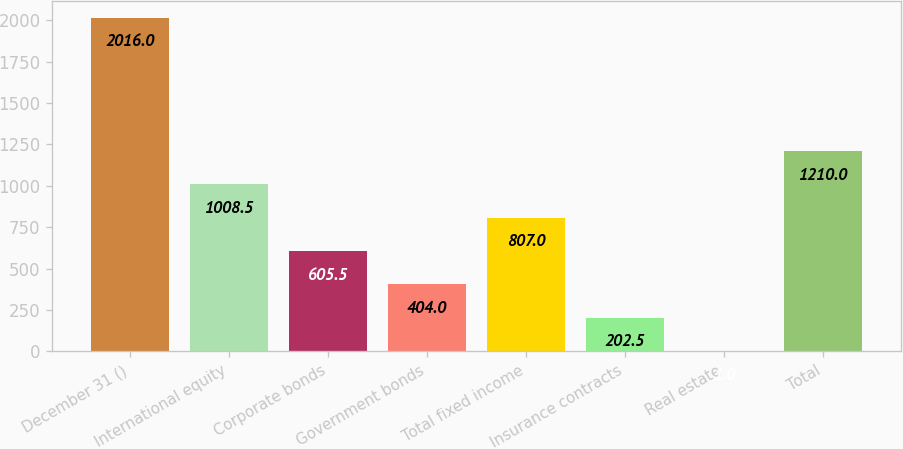<chart> <loc_0><loc_0><loc_500><loc_500><bar_chart><fcel>December 31 ()<fcel>International equity<fcel>Corporate bonds<fcel>Government bonds<fcel>Total fixed income<fcel>Insurance contracts<fcel>Real estate<fcel>Total<nl><fcel>2016<fcel>1008.5<fcel>605.5<fcel>404<fcel>807<fcel>202.5<fcel>1<fcel>1210<nl></chart> 